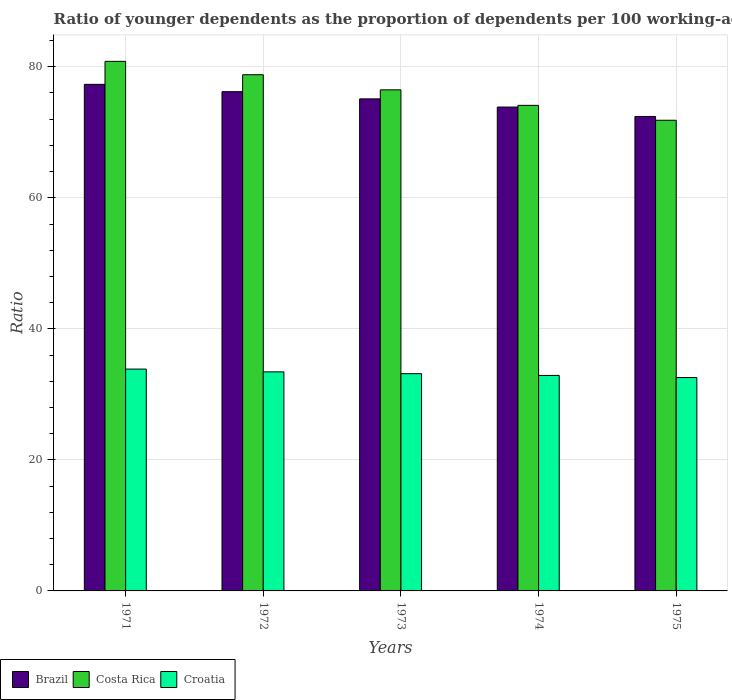How many different coloured bars are there?
Offer a very short reply. 3. What is the label of the 5th group of bars from the left?
Your response must be concise. 1975. In how many cases, is the number of bars for a given year not equal to the number of legend labels?
Your answer should be compact. 0. What is the age dependency ratio(young) in Costa Rica in 1972?
Provide a succinct answer. 78.79. Across all years, what is the maximum age dependency ratio(young) in Brazil?
Provide a succinct answer. 77.32. Across all years, what is the minimum age dependency ratio(young) in Brazil?
Keep it short and to the point. 72.42. In which year was the age dependency ratio(young) in Costa Rica maximum?
Ensure brevity in your answer.  1971. In which year was the age dependency ratio(young) in Brazil minimum?
Give a very brief answer. 1975. What is the total age dependency ratio(young) in Brazil in the graph?
Your response must be concise. 374.89. What is the difference between the age dependency ratio(young) in Brazil in 1973 and that in 1974?
Provide a succinct answer. 1.25. What is the difference between the age dependency ratio(young) in Costa Rica in 1973 and the age dependency ratio(young) in Croatia in 1972?
Provide a succinct answer. 43.05. What is the average age dependency ratio(young) in Costa Rica per year?
Offer a terse response. 76.41. In the year 1973, what is the difference between the age dependency ratio(young) in Brazil and age dependency ratio(young) in Costa Rica?
Ensure brevity in your answer.  -1.38. What is the ratio of the age dependency ratio(young) in Croatia in 1974 to that in 1975?
Provide a short and direct response. 1.01. Is the difference between the age dependency ratio(young) in Brazil in 1972 and 1974 greater than the difference between the age dependency ratio(young) in Costa Rica in 1972 and 1974?
Offer a very short reply. No. What is the difference between the highest and the second highest age dependency ratio(young) in Brazil?
Your answer should be compact. 1.12. What is the difference between the highest and the lowest age dependency ratio(young) in Brazil?
Ensure brevity in your answer.  4.9. Is the sum of the age dependency ratio(young) in Brazil in 1974 and 1975 greater than the maximum age dependency ratio(young) in Costa Rica across all years?
Keep it short and to the point. Yes. What does the 1st bar from the left in 1971 represents?
Give a very brief answer. Brazil. Is it the case that in every year, the sum of the age dependency ratio(young) in Costa Rica and age dependency ratio(young) in Brazil is greater than the age dependency ratio(young) in Croatia?
Ensure brevity in your answer.  Yes. How many bars are there?
Your answer should be very brief. 15. Are all the bars in the graph horizontal?
Your response must be concise. No. Does the graph contain any zero values?
Your answer should be compact. No. Does the graph contain grids?
Your answer should be very brief. Yes. Where does the legend appear in the graph?
Ensure brevity in your answer.  Bottom left. What is the title of the graph?
Make the answer very short. Ratio of younger dependents as the proportion of dependents per 100 working-age population. What is the label or title of the Y-axis?
Provide a short and direct response. Ratio. What is the Ratio of Brazil in 1971?
Offer a very short reply. 77.32. What is the Ratio in Costa Rica in 1971?
Make the answer very short. 80.83. What is the Ratio of Croatia in 1971?
Provide a succinct answer. 33.86. What is the Ratio in Brazil in 1972?
Ensure brevity in your answer.  76.2. What is the Ratio of Costa Rica in 1972?
Your answer should be compact. 78.79. What is the Ratio of Croatia in 1972?
Give a very brief answer. 33.43. What is the Ratio of Brazil in 1973?
Provide a succinct answer. 75.1. What is the Ratio in Costa Rica in 1973?
Make the answer very short. 76.48. What is the Ratio of Croatia in 1973?
Provide a short and direct response. 33.16. What is the Ratio in Brazil in 1974?
Your response must be concise. 73.85. What is the Ratio in Costa Rica in 1974?
Offer a terse response. 74.11. What is the Ratio in Croatia in 1974?
Offer a very short reply. 32.89. What is the Ratio in Brazil in 1975?
Your answer should be very brief. 72.42. What is the Ratio in Costa Rica in 1975?
Provide a succinct answer. 71.84. What is the Ratio in Croatia in 1975?
Your response must be concise. 32.57. Across all years, what is the maximum Ratio of Brazil?
Keep it short and to the point. 77.32. Across all years, what is the maximum Ratio of Costa Rica?
Your response must be concise. 80.83. Across all years, what is the maximum Ratio of Croatia?
Your answer should be very brief. 33.86. Across all years, what is the minimum Ratio of Brazil?
Make the answer very short. 72.42. Across all years, what is the minimum Ratio in Costa Rica?
Offer a very short reply. 71.84. Across all years, what is the minimum Ratio of Croatia?
Offer a very short reply. 32.57. What is the total Ratio in Brazil in the graph?
Your answer should be very brief. 374.89. What is the total Ratio of Costa Rica in the graph?
Provide a succinct answer. 382.04. What is the total Ratio of Croatia in the graph?
Offer a very short reply. 165.91. What is the difference between the Ratio of Brazil in 1971 and that in 1972?
Offer a very short reply. 1.12. What is the difference between the Ratio of Costa Rica in 1971 and that in 1972?
Provide a succinct answer. 2.04. What is the difference between the Ratio of Croatia in 1971 and that in 1972?
Offer a terse response. 0.42. What is the difference between the Ratio of Brazil in 1971 and that in 1973?
Your answer should be compact. 2.22. What is the difference between the Ratio in Costa Rica in 1971 and that in 1973?
Your response must be concise. 4.35. What is the difference between the Ratio of Croatia in 1971 and that in 1973?
Give a very brief answer. 0.7. What is the difference between the Ratio in Brazil in 1971 and that in 1974?
Your answer should be compact. 3.47. What is the difference between the Ratio of Costa Rica in 1971 and that in 1974?
Offer a very short reply. 6.72. What is the difference between the Ratio of Croatia in 1971 and that in 1974?
Your answer should be compact. 0.97. What is the difference between the Ratio of Brazil in 1971 and that in 1975?
Give a very brief answer. 4.9. What is the difference between the Ratio of Costa Rica in 1971 and that in 1975?
Your response must be concise. 8.99. What is the difference between the Ratio in Croatia in 1971 and that in 1975?
Provide a short and direct response. 1.29. What is the difference between the Ratio of Brazil in 1972 and that in 1973?
Keep it short and to the point. 1.1. What is the difference between the Ratio of Costa Rica in 1972 and that in 1973?
Offer a very short reply. 2.31. What is the difference between the Ratio in Croatia in 1972 and that in 1973?
Offer a terse response. 0.28. What is the difference between the Ratio in Brazil in 1972 and that in 1974?
Give a very brief answer. 2.35. What is the difference between the Ratio of Costa Rica in 1972 and that in 1974?
Offer a very short reply. 4.67. What is the difference between the Ratio in Croatia in 1972 and that in 1974?
Your answer should be very brief. 0.54. What is the difference between the Ratio in Brazil in 1972 and that in 1975?
Keep it short and to the point. 3.78. What is the difference between the Ratio of Costa Rica in 1972 and that in 1975?
Make the answer very short. 6.95. What is the difference between the Ratio in Croatia in 1972 and that in 1975?
Make the answer very short. 0.87. What is the difference between the Ratio in Brazil in 1973 and that in 1974?
Provide a succinct answer. 1.25. What is the difference between the Ratio of Costa Rica in 1973 and that in 1974?
Your answer should be compact. 2.37. What is the difference between the Ratio in Croatia in 1973 and that in 1974?
Provide a short and direct response. 0.27. What is the difference between the Ratio in Brazil in 1973 and that in 1975?
Keep it short and to the point. 2.69. What is the difference between the Ratio of Costa Rica in 1973 and that in 1975?
Offer a very short reply. 4.64. What is the difference between the Ratio of Croatia in 1973 and that in 1975?
Offer a terse response. 0.59. What is the difference between the Ratio in Brazil in 1974 and that in 1975?
Make the answer very short. 1.44. What is the difference between the Ratio of Costa Rica in 1974 and that in 1975?
Ensure brevity in your answer.  2.27. What is the difference between the Ratio in Croatia in 1974 and that in 1975?
Provide a succinct answer. 0.32. What is the difference between the Ratio in Brazil in 1971 and the Ratio in Costa Rica in 1972?
Your answer should be compact. -1.47. What is the difference between the Ratio in Brazil in 1971 and the Ratio in Croatia in 1972?
Keep it short and to the point. 43.88. What is the difference between the Ratio in Costa Rica in 1971 and the Ratio in Croatia in 1972?
Provide a short and direct response. 47.39. What is the difference between the Ratio of Brazil in 1971 and the Ratio of Costa Rica in 1973?
Ensure brevity in your answer.  0.84. What is the difference between the Ratio of Brazil in 1971 and the Ratio of Croatia in 1973?
Ensure brevity in your answer.  44.16. What is the difference between the Ratio of Costa Rica in 1971 and the Ratio of Croatia in 1973?
Ensure brevity in your answer.  47.67. What is the difference between the Ratio of Brazil in 1971 and the Ratio of Costa Rica in 1974?
Keep it short and to the point. 3.21. What is the difference between the Ratio of Brazil in 1971 and the Ratio of Croatia in 1974?
Keep it short and to the point. 44.43. What is the difference between the Ratio of Costa Rica in 1971 and the Ratio of Croatia in 1974?
Make the answer very short. 47.94. What is the difference between the Ratio of Brazil in 1971 and the Ratio of Costa Rica in 1975?
Your response must be concise. 5.48. What is the difference between the Ratio of Brazil in 1971 and the Ratio of Croatia in 1975?
Give a very brief answer. 44.75. What is the difference between the Ratio in Costa Rica in 1971 and the Ratio in Croatia in 1975?
Ensure brevity in your answer.  48.26. What is the difference between the Ratio in Brazil in 1972 and the Ratio in Costa Rica in 1973?
Offer a very short reply. -0.28. What is the difference between the Ratio of Brazil in 1972 and the Ratio of Croatia in 1973?
Provide a short and direct response. 43.04. What is the difference between the Ratio of Costa Rica in 1972 and the Ratio of Croatia in 1973?
Provide a short and direct response. 45.63. What is the difference between the Ratio in Brazil in 1972 and the Ratio in Costa Rica in 1974?
Provide a succinct answer. 2.09. What is the difference between the Ratio of Brazil in 1972 and the Ratio of Croatia in 1974?
Keep it short and to the point. 43.31. What is the difference between the Ratio in Costa Rica in 1972 and the Ratio in Croatia in 1974?
Offer a terse response. 45.9. What is the difference between the Ratio in Brazil in 1972 and the Ratio in Costa Rica in 1975?
Your response must be concise. 4.36. What is the difference between the Ratio in Brazil in 1972 and the Ratio in Croatia in 1975?
Offer a very short reply. 43.63. What is the difference between the Ratio of Costa Rica in 1972 and the Ratio of Croatia in 1975?
Your response must be concise. 46.22. What is the difference between the Ratio in Brazil in 1973 and the Ratio in Croatia in 1974?
Make the answer very short. 42.21. What is the difference between the Ratio of Costa Rica in 1973 and the Ratio of Croatia in 1974?
Give a very brief answer. 43.59. What is the difference between the Ratio in Brazil in 1973 and the Ratio in Costa Rica in 1975?
Make the answer very short. 3.27. What is the difference between the Ratio in Brazil in 1973 and the Ratio in Croatia in 1975?
Your answer should be very brief. 42.53. What is the difference between the Ratio in Costa Rica in 1973 and the Ratio in Croatia in 1975?
Your answer should be very brief. 43.91. What is the difference between the Ratio in Brazil in 1974 and the Ratio in Costa Rica in 1975?
Your answer should be very brief. 2.02. What is the difference between the Ratio of Brazil in 1974 and the Ratio of Croatia in 1975?
Provide a short and direct response. 41.28. What is the difference between the Ratio in Costa Rica in 1974 and the Ratio in Croatia in 1975?
Keep it short and to the point. 41.54. What is the average Ratio of Brazil per year?
Keep it short and to the point. 74.98. What is the average Ratio of Costa Rica per year?
Your answer should be compact. 76.41. What is the average Ratio in Croatia per year?
Give a very brief answer. 33.18. In the year 1971, what is the difference between the Ratio in Brazil and Ratio in Costa Rica?
Ensure brevity in your answer.  -3.51. In the year 1971, what is the difference between the Ratio of Brazil and Ratio of Croatia?
Your response must be concise. 43.46. In the year 1971, what is the difference between the Ratio of Costa Rica and Ratio of Croatia?
Provide a succinct answer. 46.97. In the year 1972, what is the difference between the Ratio of Brazil and Ratio of Costa Rica?
Your response must be concise. -2.58. In the year 1972, what is the difference between the Ratio in Brazil and Ratio in Croatia?
Make the answer very short. 42.77. In the year 1972, what is the difference between the Ratio in Costa Rica and Ratio in Croatia?
Offer a terse response. 45.35. In the year 1973, what is the difference between the Ratio in Brazil and Ratio in Costa Rica?
Your response must be concise. -1.38. In the year 1973, what is the difference between the Ratio in Brazil and Ratio in Croatia?
Your answer should be compact. 41.95. In the year 1973, what is the difference between the Ratio in Costa Rica and Ratio in Croatia?
Ensure brevity in your answer.  43.32. In the year 1974, what is the difference between the Ratio of Brazil and Ratio of Costa Rica?
Ensure brevity in your answer.  -0.26. In the year 1974, what is the difference between the Ratio of Brazil and Ratio of Croatia?
Your answer should be very brief. 40.96. In the year 1974, what is the difference between the Ratio of Costa Rica and Ratio of Croatia?
Give a very brief answer. 41.22. In the year 1975, what is the difference between the Ratio of Brazil and Ratio of Costa Rica?
Your response must be concise. 0.58. In the year 1975, what is the difference between the Ratio of Brazil and Ratio of Croatia?
Keep it short and to the point. 39.85. In the year 1975, what is the difference between the Ratio of Costa Rica and Ratio of Croatia?
Offer a very short reply. 39.27. What is the ratio of the Ratio in Brazil in 1971 to that in 1972?
Your response must be concise. 1.01. What is the ratio of the Ratio of Costa Rica in 1971 to that in 1972?
Offer a very short reply. 1.03. What is the ratio of the Ratio of Croatia in 1971 to that in 1972?
Provide a succinct answer. 1.01. What is the ratio of the Ratio of Brazil in 1971 to that in 1973?
Keep it short and to the point. 1.03. What is the ratio of the Ratio in Costa Rica in 1971 to that in 1973?
Offer a terse response. 1.06. What is the ratio of the Ratio in Croatia in 1971 to that in 1973?
Your answer should be compact. 1.02. What is the ratio of the Ratio of Brazil in 1971 to that in 1974?
Provide a short and direct response. 1.05. What is the ratio of the Ratio in Costa Rica in 1971 to that in 1974?
Provide a succinct answer. 1.09. What is the ratio of the Ratio of Croatia in 1971 to that in 1974?
Provide a short and direct response. 1.03. What is the ratio of the Ratio of Brazil in 1971 to that in 1975?
Your answer should be compact. 1.07. What is the ratio of the Ratio in Costa Rica in 1971 to that in 1975?
Provide a short and direct response. 1.13. What is the ratio of the Ratio of Croatia in 1971 to that in 1975?
Your response must be concise. 1.04. What is the ratio of the Ratio in Brazil in 1972 to that in 1973?
Provide a short and direct response. 1.01. What is the ratio of the Ratio in Costa Rica in 1972 to that in 1973?
Make the answer very short. 1.03. What is the ratio of the Ratio in Croatia in 1972 to that in 1973?
Your response must be concise. 1.01. What is the ratio of the Ratio in Brazil in 1972 to that in 1974?
Make the answer very short. 1.03. What is the ratio of the Ratio of Costa Rica in 1972 to that in 1974?
Offer a terse response. 1.06. What is the ratio of the Ratio in Croatia in 1972 to that in 1974?
Provide a short and direct response. 1.02. What is the ratio of the Ratio in Brazil in 1972 to that in 1975?
Make the answer very short. 1.05. What is the ratio of the Ratio in Costa Rica in 1972 to that in 1975?
Make the answer very short. 1.1. What is the ratio of the Ratio of Croatia in 1972 to that in 1975?
Ensure brevity in your answer.  1.03. What is the ratio of the Ratio in Brazil in 1973 to that in 1974?
Provide a succinct answer. 1.02. What is the ratio of the Ratio of Costa Rica in 1973 to that in 1974?
Your answer should be compact. 1.03. What is the ratio of the Ratio in Brazil in 1973 to that in 1975?
Offer a terse response. 1.04. What is the ratio of the Ratio of Costa Rica in 1973 to that in 1975?
Make the answer very short. 1.06. What is the ratio of the Ratio in Croatia in 1973 to that in 1975?
Offer a terse response. 1.02. What is the ratio of the Ratio of Brazil in 1974 to that in 1975?
Your answer should be very brief. 1.02. What is the ratio of the Ratio in Costa Rica in 1974 to that in 1975?
Offer a very short reply. 1.03. What is the ratio of the Ratio of Croatia in 1974 to that in 1975?
Offer a very short reply. 1.01. What is the difference between the highest and the second highest Ratio of Brazil?
Keep it short and to the point. 1.12. What is the difference between the highest and the second highest Ratio in Costa Rica?
Provide a succinct answer. 2.04. What is the difference between the highest and the second highest Ratio in Croatia?
Offer a terse response. 0.42. What is the difference between the highest and the lowest Ratio of Brazil?
Ensure brevity in your answer.  4.9. What is the difference between the highest and the lowest Ratio of Costa Rica?
Provide a succinct answer. 8.99. What is the difference between the highest and the lowest Ratio in Croatia?
Offer a very short reply. 1.29. 